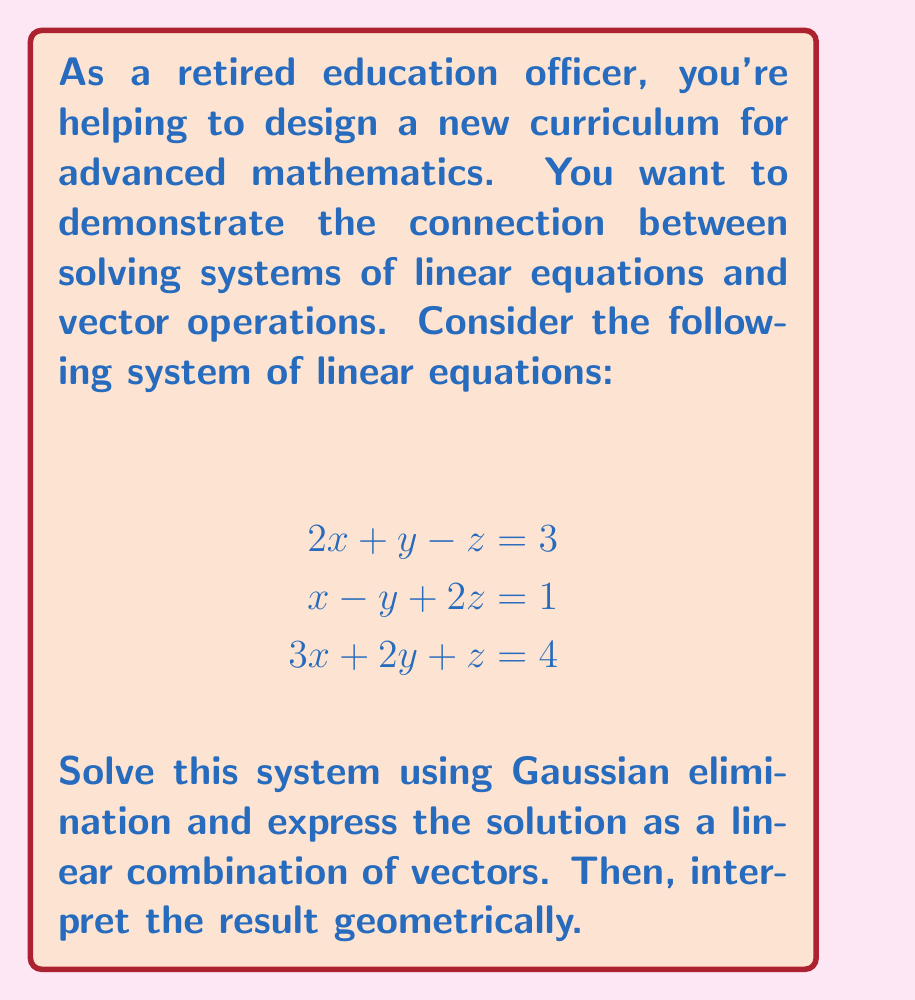Show me your answer to this math problem. Let's solve this step-by-step:

1) First, we'll write the augmented matrix for this system:

   $$\begin{bmatrix}
   2 & 1 & -1 & 3 \\
   1 & -1 & 2 & 1 \\
   3 & 2 & 1 & 4
   \end{bmatrix}$$

2) Now, we'll perform Gaussian elimination:
   
   R2 → R2 - $\frac{1}{2}$R1:
   $$\begin{bmatrix}
   2 & 1 & -1 & 3 \\
   0 & -\frac{3}{2} & \frac{5}{2} & -\frac{1}{2} \\
   3 & 2 & 1 & 4
   \end{bmatrix}$$

   R3 → R3 - $\frac{3}{2}$R1:
   $$\begin{bmatrix}
   2 & 1 & -1 & 3 \\
   0 & -\frac{3}{2} & \frac{5}{2} & -\frac{1}{2} \\
   0 & \frac{1}{2} & \frac{5}{2} & -\frac{1}{2}
   \end{bmatrix}$$

   R3 → R3 + $\frac{1}{3}$R2:
   $$\begin{bmatrix}
   2 & 1 & -1 & 3 \\
   0 & -\frac{3}{2} & \frac{5}{2} & -\frac{1}{2} \\
   0 & 0 & 3 & -\frac{2}{3}
   \end{bmatrix}$$

3) Now we have an upper triangular matrix. We can solve by back-substitution:

   $z = -\frac{2}{9}$
   
   $y = \frac{1}{3} - \frac{5}{3}z = \frac{1}{3} + \frac{10}{27} = \frac{19}{27}$
   
   $x = \frac{3}{2} - \frac{1}{2}y + \frac{1}{2}z = \frac{3}{2} - \frac{19}{54} + \frac{1}{18} = \frac{41}{54}$

4) Now, let's express this as a linear combination of vectors:

   $$\begin{pmatrix} x \\ y \\ z \end{pmatrix} = 
   \frac{41}{54}\begin{pmatrix} 1 \\ 0 \\ 0 \end{pmatrix} + 
   \frac{19}{27}\begin{pmatrix} 0 \\ 1 \\ 0 \end{pmatrix} + 
   (-\frac{2}{9})\begin{pmatrix} 0 \\ 0 \\ 1 \end{pmatrix}$$

5) Geometrically, this represents a point in 3D space. The coefficients $\frac{41}{54}$, $\frac{19}{27}$, and $-\frac{2}{9}$ represent the distances along the x, y, and z axes respectively from the origin to this point.
Answer: $\begin{pmatrix} x \\ y \\ z \end{pmatrix} = \begin{pmatrix} \frac{41}{54} \\ \frac{19}{27} \\ -\frac{2}{9} \end{pmatrix}$ 